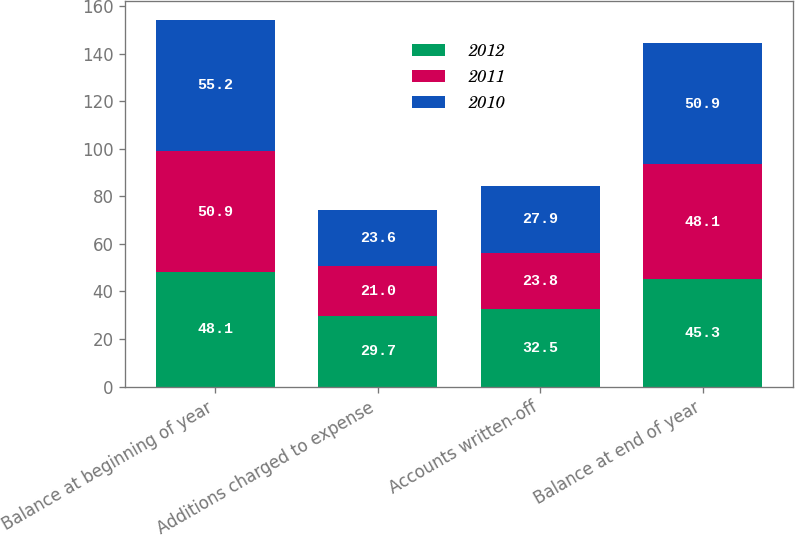Convert chart. <chart><loc_0><loc_0><loc_500><loc_500><stacked_bar_chart><ecel><fcel>Balance at beginning of year<fcel>Additions charged to expense<fcel>Accounts written-off<fcel>Balance at end of year<nl><fcel>2012<fcel>48.1<fcel>29.7<fcel>32.5<fcel>45.3<nl><fcel>2011<fcel>50.9<fcel>21<fcel>23.8<fcel>48.1<nl><fcel>2010<fcel>55.2<fcel>23.6<fcel>27.9<fcel>50.9<nl></chart> 